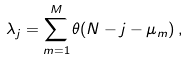Convert formula to latex. <formula><loc_0><loc_0><loc_500><loc_500>\lambda _ { j } = \sum _ { m = 1 } ^ { M } \theta ( N - j - \mu _ { m } ) \, ,</formula> 